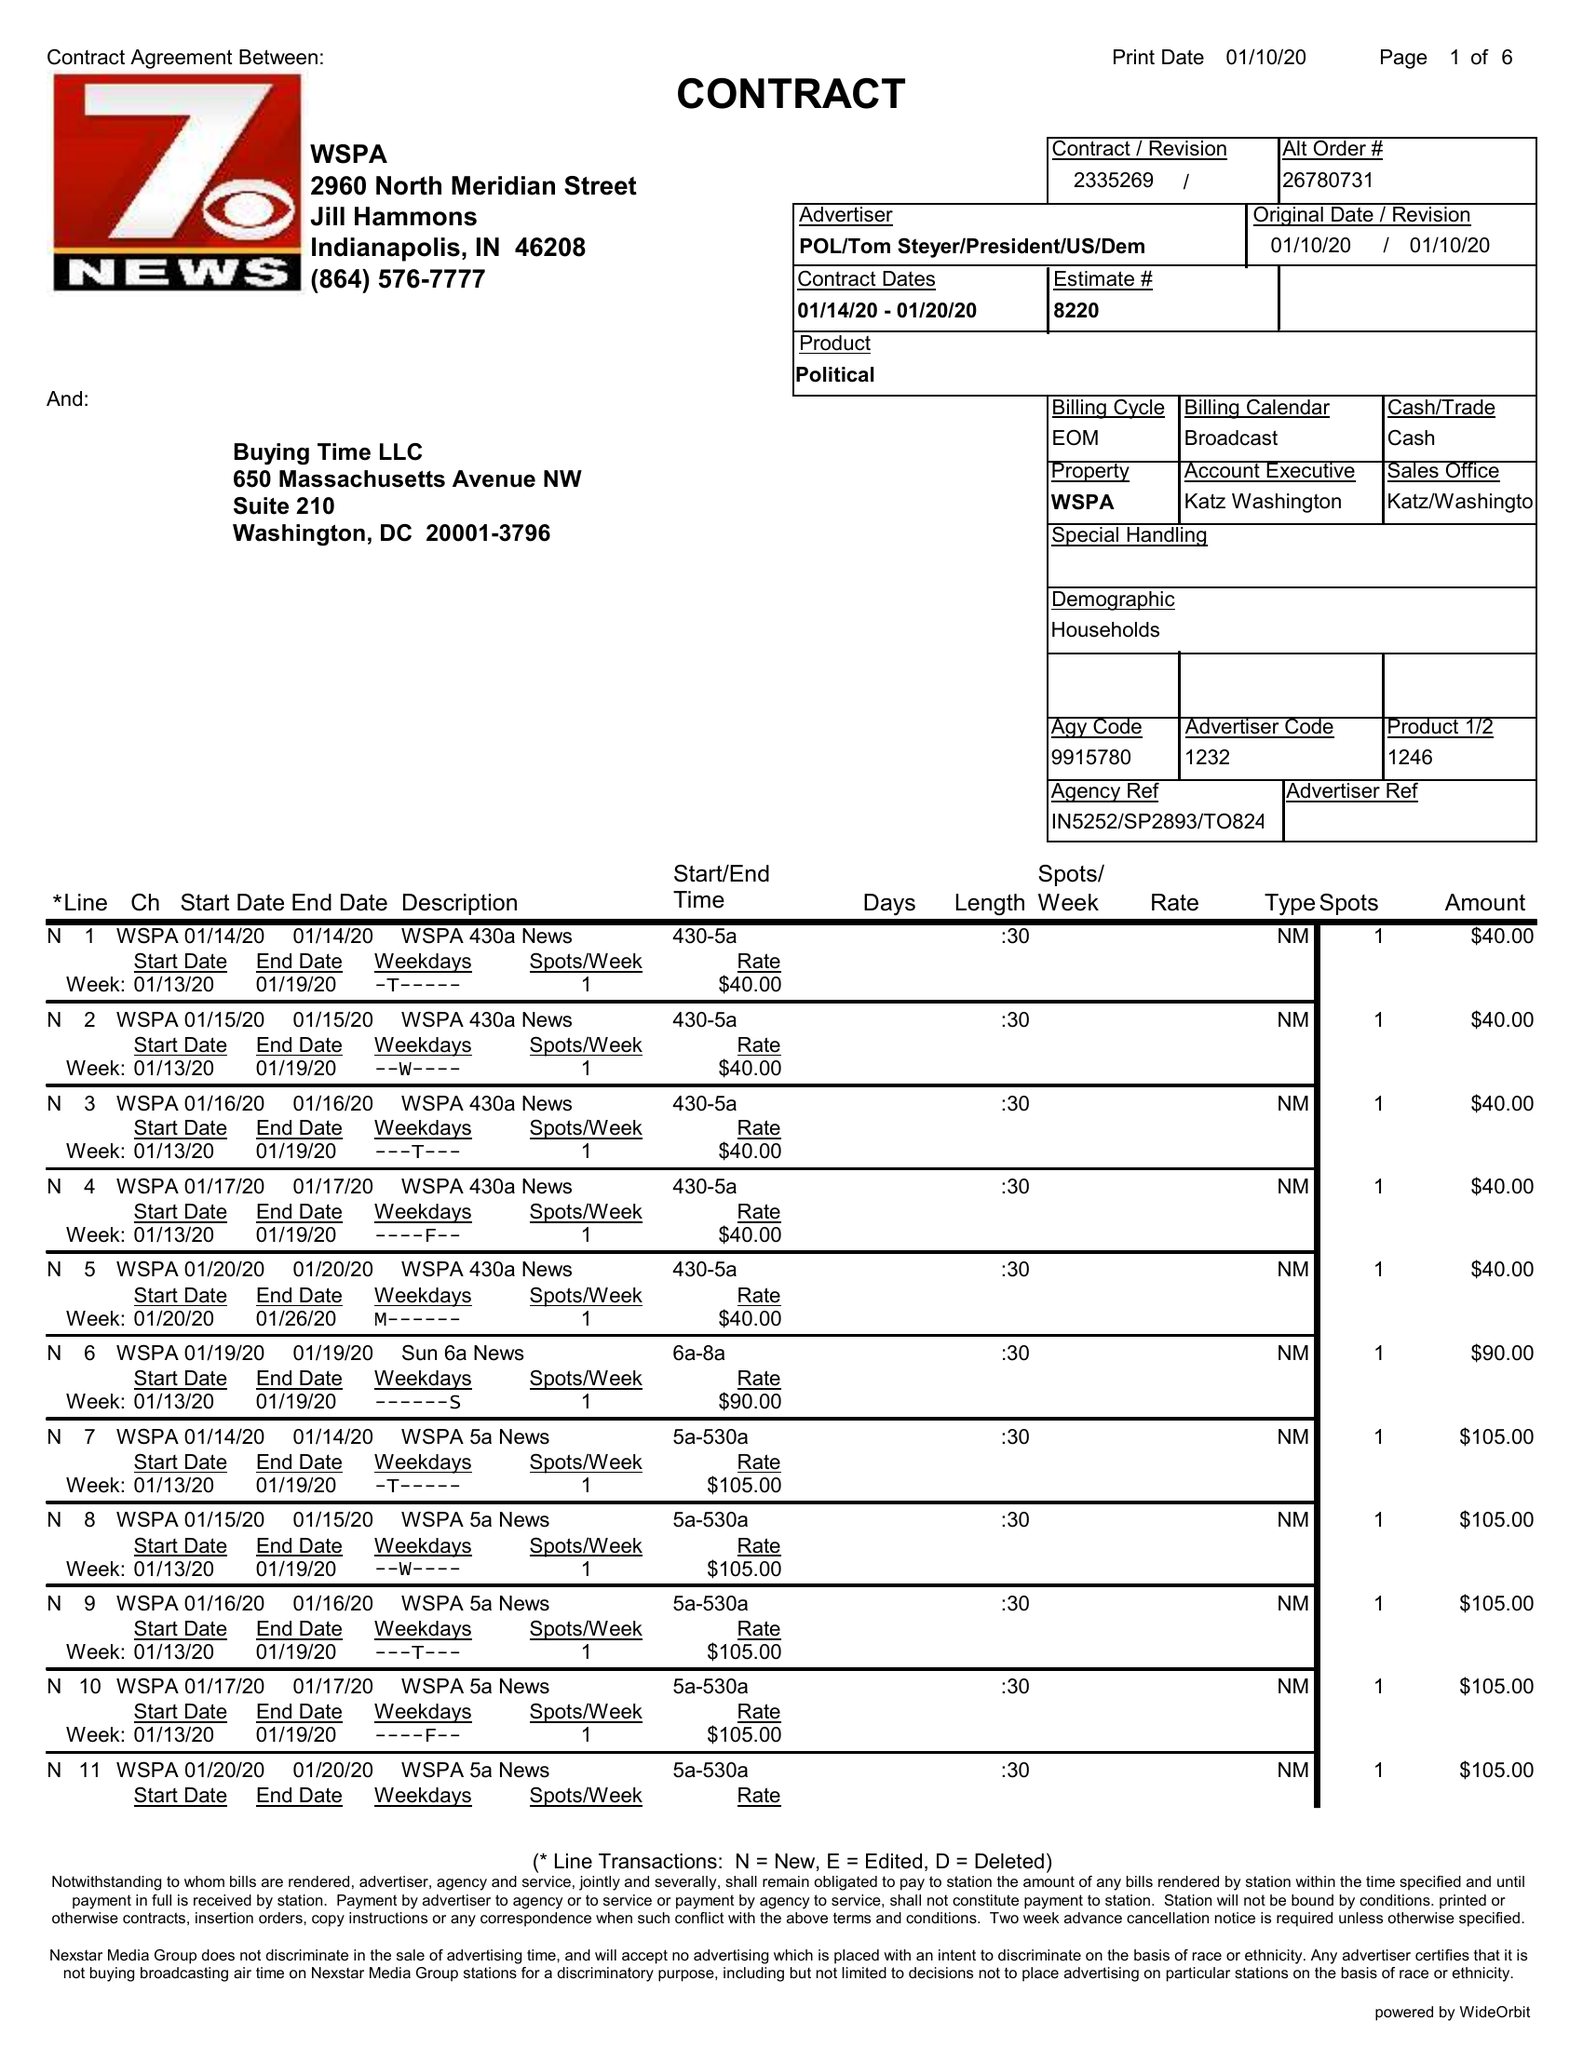What is the value for the flight_to?
Answer the question using a single word or phrase. 01/20/20 